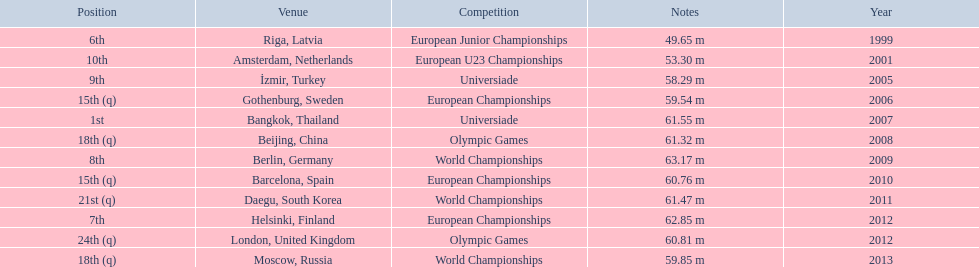Which competitions has gerhard mayer competed in since 1999? European Junior Championships, European U23 Championships, Universiade, European Championships, Universiade, Olympic Games, World Championships, European Championships, World Championships, European Championships, Olympic Games, World Championships. Of these competition, in which ones did he throw at least 60 m? Universiade, Olympic Games, World Championships, European Championships, World Championships, European Championships, Olympic Games. Of these throws, which was his longest? 63.17 m. 